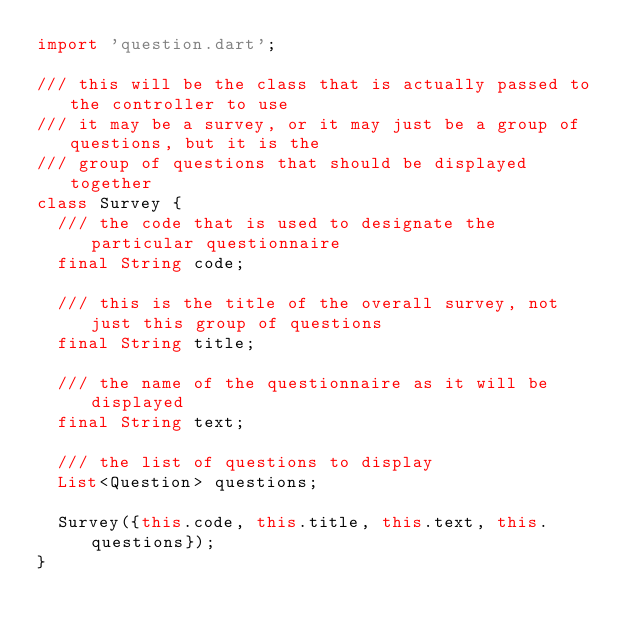<code> <loc_0><loc_0><loc_500><loc_500><_Dart_>import 'question.dart';

/// this will be the class that is actually passed to the controller to use
/// it may be a survey, or it may just be a group of questions, but it is the
/// group of questions that should be displayed together
class Survey {
  /// the code that is used to designate the particular questionnaire
  final String code;

  /// this is the title of the overall survey, not just this group of questions
  final String title;

  /// the name of the questionnaire as it will be displayed
  final String text;

  /// the list of questions to display
  List<Question> questions;

  Survey({this.code, this.title, this.text, this.questions});
}
</code> 